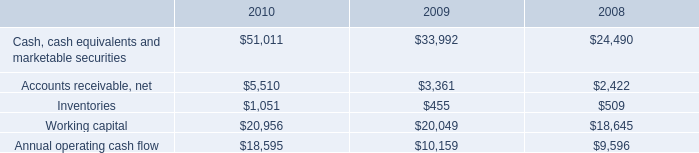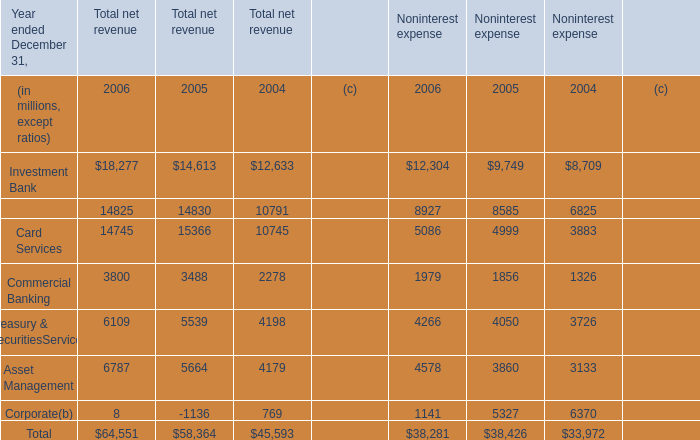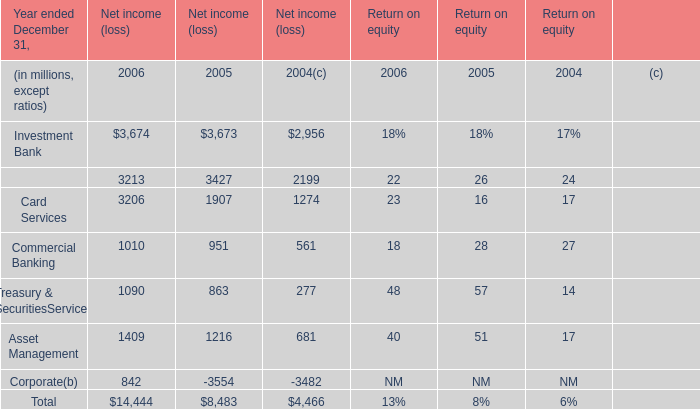what is the highest total amount of Investment Bank? (in million) 
Computations: (18277 + 12304)
Answer: 30581.0. 